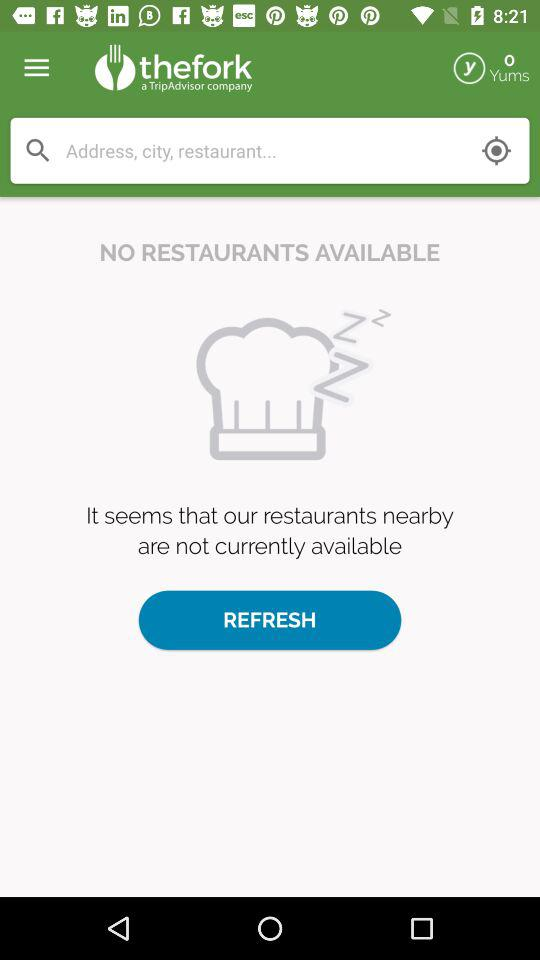What is the name of the application? The name of the application is "thefork". 